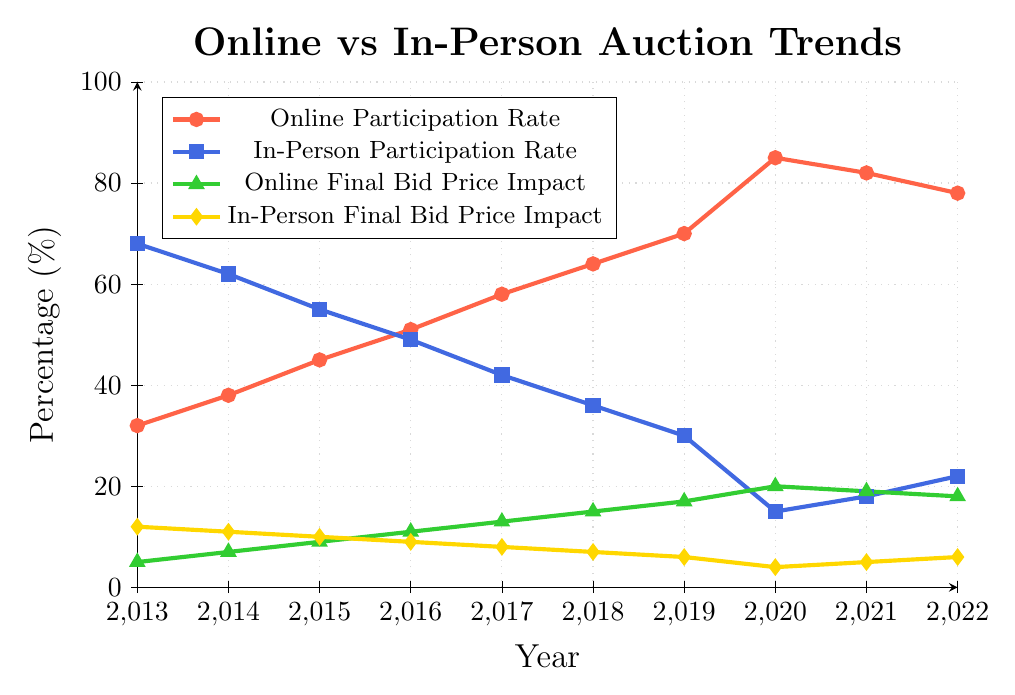What's the percentage increase in online participation rate from 2013 to 2022? To find the percentage increase, subtract the online participation rate in 2013 (32%) from the rate in 2022 (78%) and then divide by the 2013 rate. Finally, multiply by 100 to get the percentage increase: \(\frac{78 - 32}{32} \times 100 = 143.75\% \).
Answer: 143.75% In which year did the online participation rate surpass the in-person participation rate? From the chart, observe where the online participation rate (red line) rises above the in-person participation rate (blue line). This occurs in the year 2016 when the online rate is 51% and the in-person rate is 49%.
Answer: 2016 What's the average final bid price impact for online auctions from 2013 to 2022? Sum the final bid price impacts for online auctions from each year (5+7+9+11+13+15+17+20+19+18 = 134) and then divide by the number of years (10): 134/10 = 13.4%.
Answer: 13.4% Between 2020 and 2021, did the in-person final bid price impact increase or decrease? Compare the in-person final bid price impact in 2020 (4%) to the impact in 2021 (5%). The impact increased from 4% to 5%.
Answer: Increased Which year has the highest combined participation rate (online + in-person)? To find the highest combined rate, add the online and in-person participation rates for each year and look for the maximum: 
2013: 32 + 68 = 100,
2014: 38 + 62 = 100,
2015: 45 + 55 = 100,
2016: 51 + 49 = 100,
2017: 58 + 42 = 100,
2018: 64 + 36 = 100,
2019: 70 + 30 = 100,
2020: 85 + 15 = 100,
2021: 82 + 18 = 100,
2022: 78 + 22 = 100. 
All years have a combined participation rate of 100%.
Answer: All years have 100% What is the trend of the in-person final bid price impact over the last decade? To determine the trend, observe the in-person final bid price impact (yellow line) from 2013 to 2022. The value decreases from 12% in 2013 to 6% in 2022.
Answer: Decreasing Which participation rate changed more significantly from 2019 to 2020, online or in-person? Calculate the difference for both rates:
Online: \(85 - 70 = 15\%\),
In-Person: \(30 - 15 = 15\%\).
Both participation rates changed equally by 15%.
Answer: Both changed equally How many years did the final bid price impact for in-person auctions decrease consecutively? Starting from 2013, observe the yellow line: the impact decreases every year from 2013 (12%) to 2020 (4%) for a total of 7 years.
Answer: 7 years 